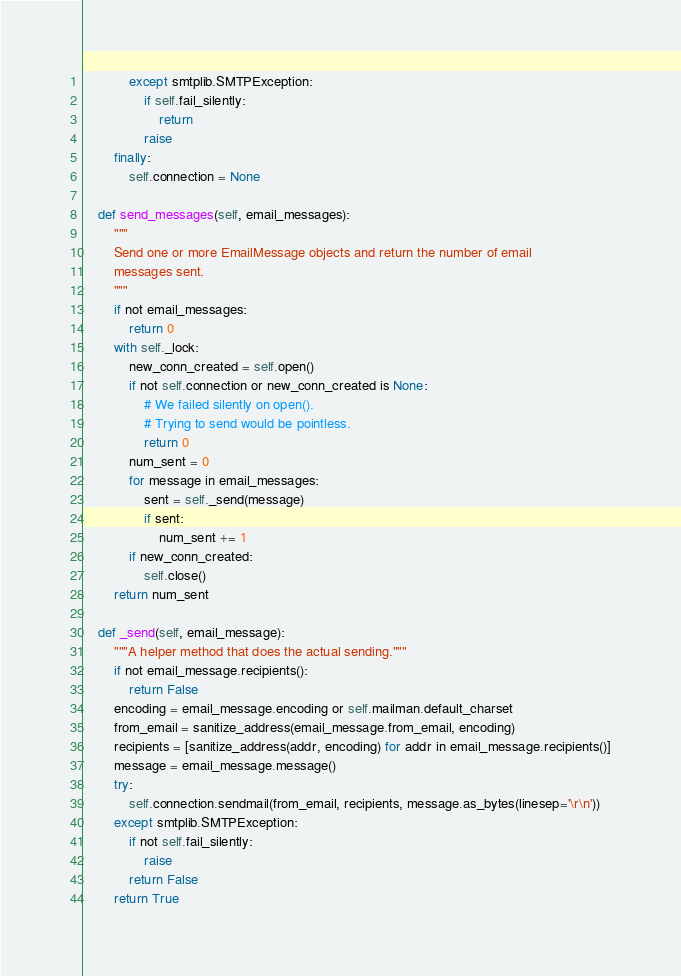Convert code to text. <code><loc_0><loc_0><loc_500><loc_500><_Python_>            except smtplib.SMTPException:
                if self.fail_silently:
                    return
                raise
        finally:
            self.connection = None

    def send_messages(self, email_messages):
        """
        Send one or more EmailMessage objects and return the number of email
        messages sent.
        """
        if not email_messages:
            return 0
        with self._lock:
            new_conn_created = self.open()
            if not self.connection or new_conn_created is None:
                # We failed silently on open().
                # Trying to send would be pointless.
                return 0
            num_sent = 0
            for message in email_messages:
                sent = self._send(message)
                if sent:
                    num_sent += 1
            if new_conn_created:
                self.close()
        return num_sent

    def _send(self, email_message):
        """A helper method that does the actual sending."""
        if not email_message.recipients():
            return False
        encoding = email_message.encoding or self.mailman.default_charset
        from_email = sanitize_address(email_message.from_email, encoding)
        recipients = [sanitize_address(addr, encoding) for addr in email_message.recipients()]
        message = email_message.message()
        try:
            self.connection.sendmail(from_email, recipients, message.as_bytes(linesep='\r\n'))
        except smtplib.SMTPException:
            if not self.fail_silently:
                raise
            return False
        return True
</code> 